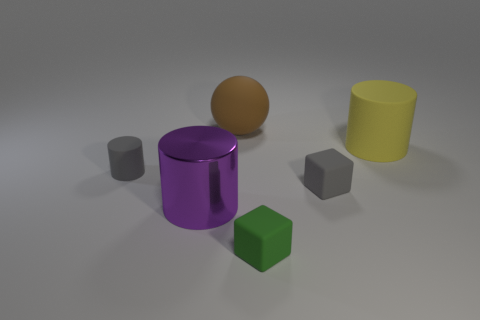Can you describe the layout of the objects and their colors? Certainly! In the image, there is a collection of geometric shapes with different colors. At the forefront, there is a vibrant purple cylindrical object with a reflective surface. Behind it, there is a small gray cylinder, similar in color to two cube-shaped objects. On the right, we see a large yellow cylinder, while a lone spherical object with a brown hue rests towards the left. All these items are placed on a flat surface with a neutral tone, which helps to highlight their individual colors. 